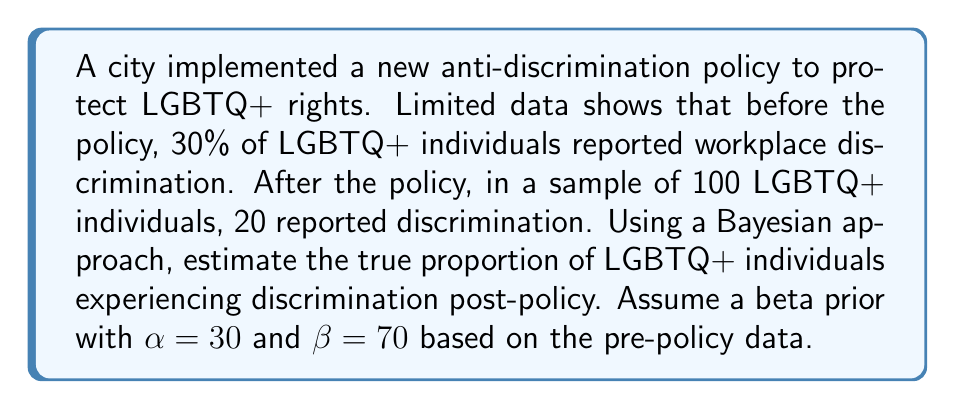What is the answer to this math problem? 1. We'll use Bayesian inference with a beta-binomial model:
   Prior: $Beta(\alpha, \beta)$ where $\alpha=30$, $\beta=70$
   Likelihood: Binomial(n, θ) where n=100, x=20 (reported discrimination)

2. The posterior distribution is also a beta distribution:
   $Posterior = Beta(\alpha + x, \beta + n - x)$
   $= Beta(30 + 20, 70 + 100 - 20) = Beta(50, 150)$

3. The expected value (mean) of a beta distribution is:
   $E[\theta] = \frac{\alpha}{\alpha + \beta}$

4. Calculate the posterior mean:
   $E[\theta|x] = \frac{50}{50 + 150} = \frac{50}{200} = 0.25$

5. Convert to a percentage:
   $0.25 * 100\% = 25\%$

This approach allows us to infer the impact of the policy change by combining prior knowledge with new, limited data.
Answer: 25% 